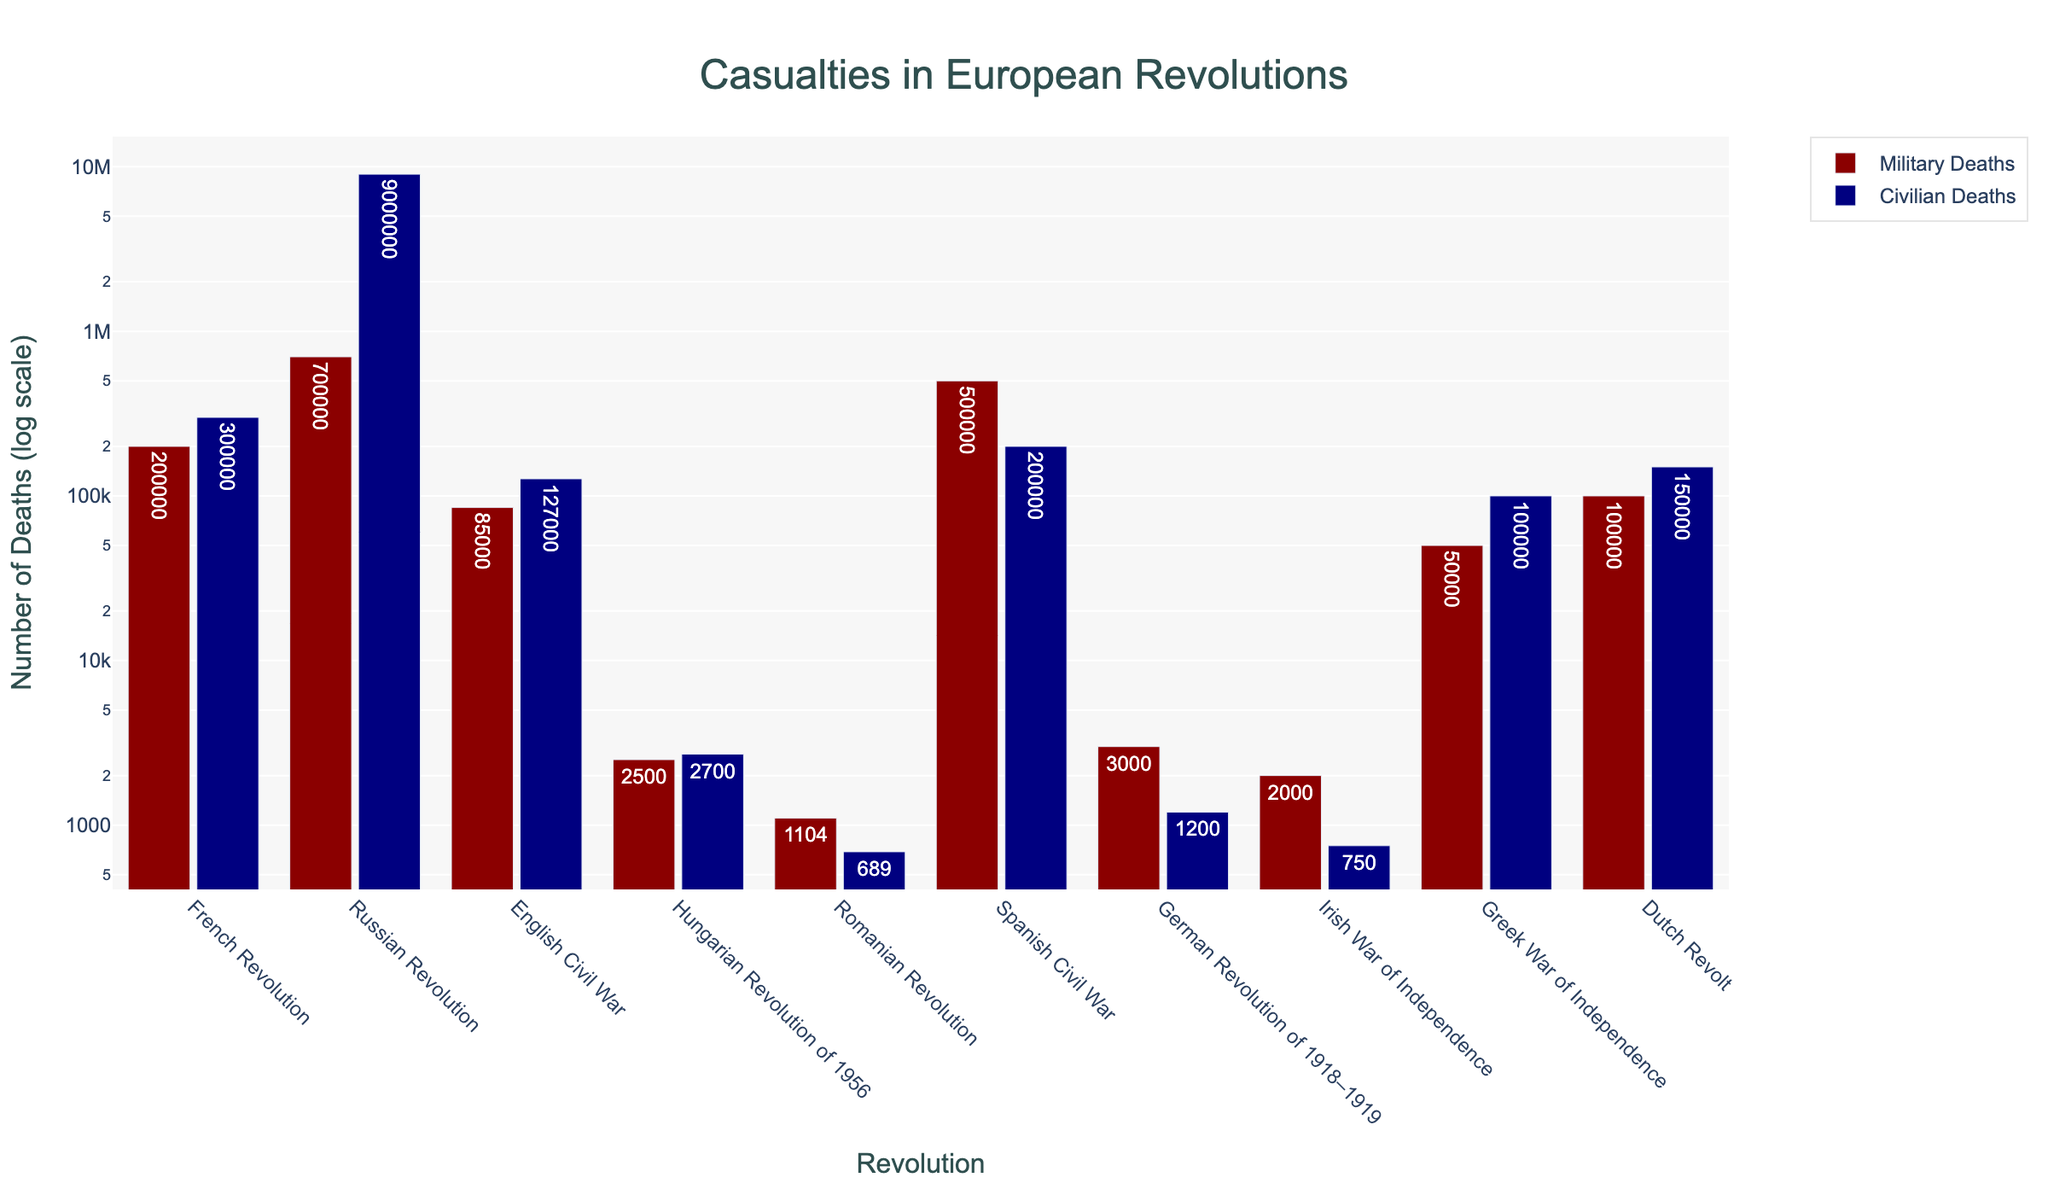Which revolution had the highest civilian deaths? The highest civilian deaths are indicated by the tallest navy-colored bar. The Russian Revolution has the tallest navy-colored bar indicating the highest civilian deaths.
Answer: Russian Revolution How many more military deaths were there in the Russian Revolution compared to the Hungarian Revolution of 1956? The number of military deaths for the Russian Revolution is 700,000 and for the Hungarian Revolution of 1956 is 2,500. Subtracting the two gives 700,000 - 2,500.
Answer: 697,500 What is the ratio of civilian deaths to military deaths for the French Revolution? The number of civilian deaths for the French Revolution is 300,000 and military deaths are 200,000. The ratio is calculated as 300,000 / 200,000.
Answer: 1.5 Which two revolutions have the closest numbers of military deaths? By comparing the heights of the dark red bars, the Hungarian Revolution of 1956 (2,500) and the Irish War of Independence (2,000) have the closest numbers of military deaths, differing by just 500.
Answer: Hungarian Revolution of 1956 and Irish War of Independence Are civilian deaths generally higher than military deaths across the revolutions? By observing the overall height of the navy-colored bars (civilian deaths) and dark red bars (military deaths), it is evident that in most revolutions, the navy-colored bars are taller than the dark red bars.
Answer: Yes Which revolution had the lowest number of civilian deaths, and what is the number? The shortest navy-colored bar indicates the lowest number of civilian deaths. The Romanian Revolution has the shortest navy-colored bar with 689 civilian deaths.
Answer: Romanian Revolution, 689 What is the total number of civilian deaths in the German Revolution of 1918–1919 and the English Civil War combined? The civilian deaths in the German Revolution of 1918–1919 are 1,200 and in the English Civil War are 127,000. Adding them together gives 1,200 + 127,000.
Answer: 128,200 How does the number of military deaths in the Spanish Civil War compare to the Greek War of Independence? The Spanish Civil War has 500,000 military deaths while the Greek War of Independence has 50,000 military deaths. Comparing these values shows that the Spanish Civil War had significantly more military deaths by 450,000.
Answer: Spanish Civil War had more Which revolution shows an almost equal number of military and civilian deaths? The Hungarian Revolution of 1956 shows bars of very similar height for both navy (civilian deaths) and dark red (military deaths), indicating nearly equal numbers: 2,500 military deaths and 2,700 civilian deaths.
Answer: Hungarian Revolution of 1956 What is the combined total of military and civilian deaths for the Romanian Revolution? Adding together the military and civilian deaths for the Romanian Revolution: 1,104 military deaths + 689 civilian deaths.
Answer: 1,793 